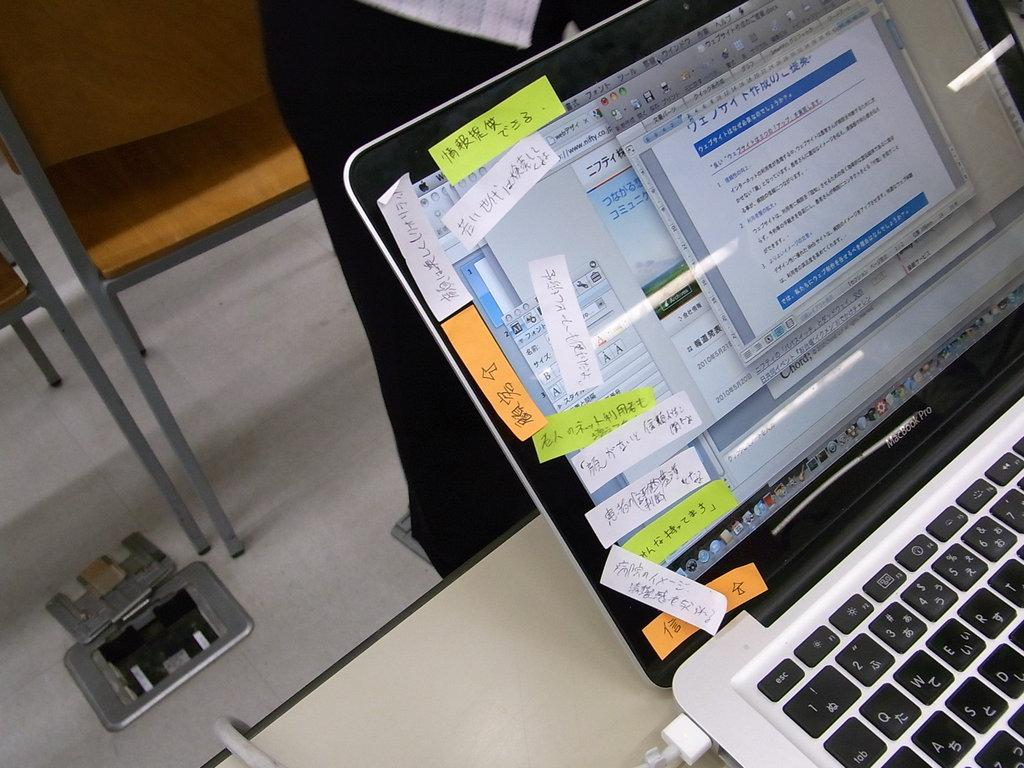<image>
Give a short and clear explanation of the subsequent image. A bunch of sticky notes are placed on the side of a Macbook Pro. 